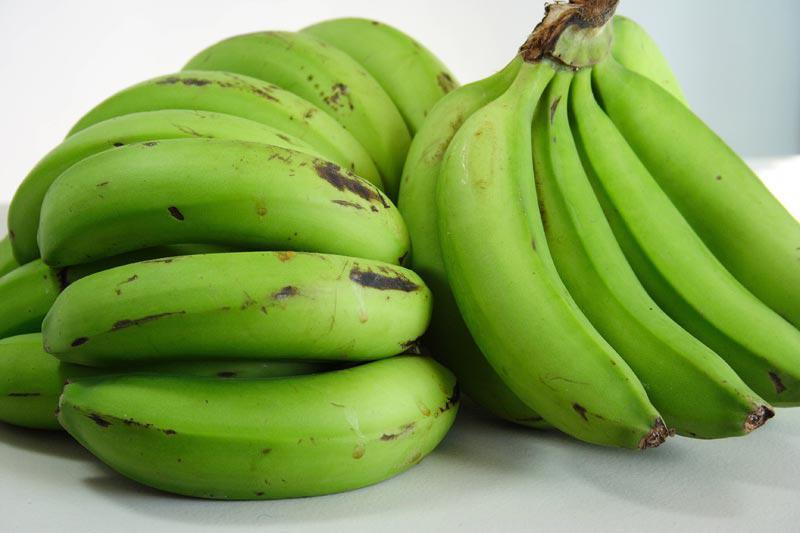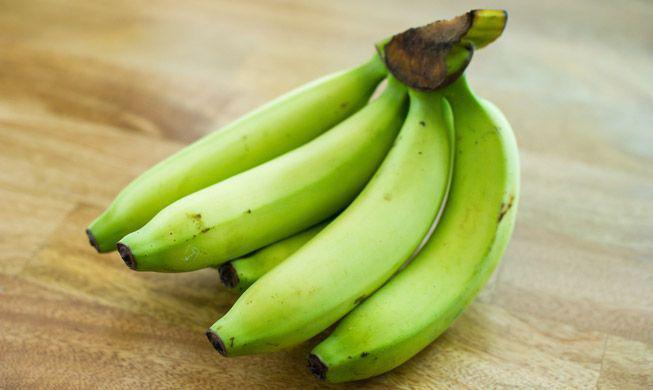The first image is the image on the left, the second image is the image on the right. Considering the images on both sides, is "One image includes only one small bunch of green bananas, with no more than five bananas visible." valid? Answer yes or no. Yes. The first image is the image on the left, the second image is the image on the right. Assess this claim about the two images: "There is an image with one bunch of unripe bananas, and another image with multiple bunches.". Correct or not? Answer yes or no. Yes. 